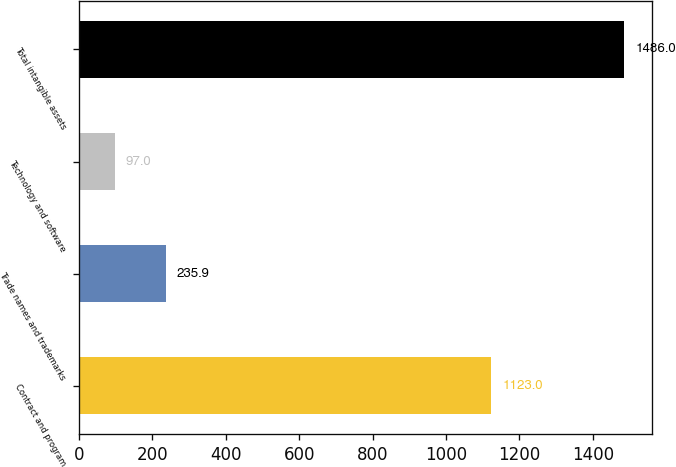Convert chart. <chart><loc_0><loc_0><loc_500><loc_500><bar_chart><fcel>Contract and program<fcel>Trade names and trademarks<fcel>Technology and software<fcel>Total intangible assets<nl><fcel>1123<fcel>235.9<fcel>97<fcel>1486<nl></chart> 